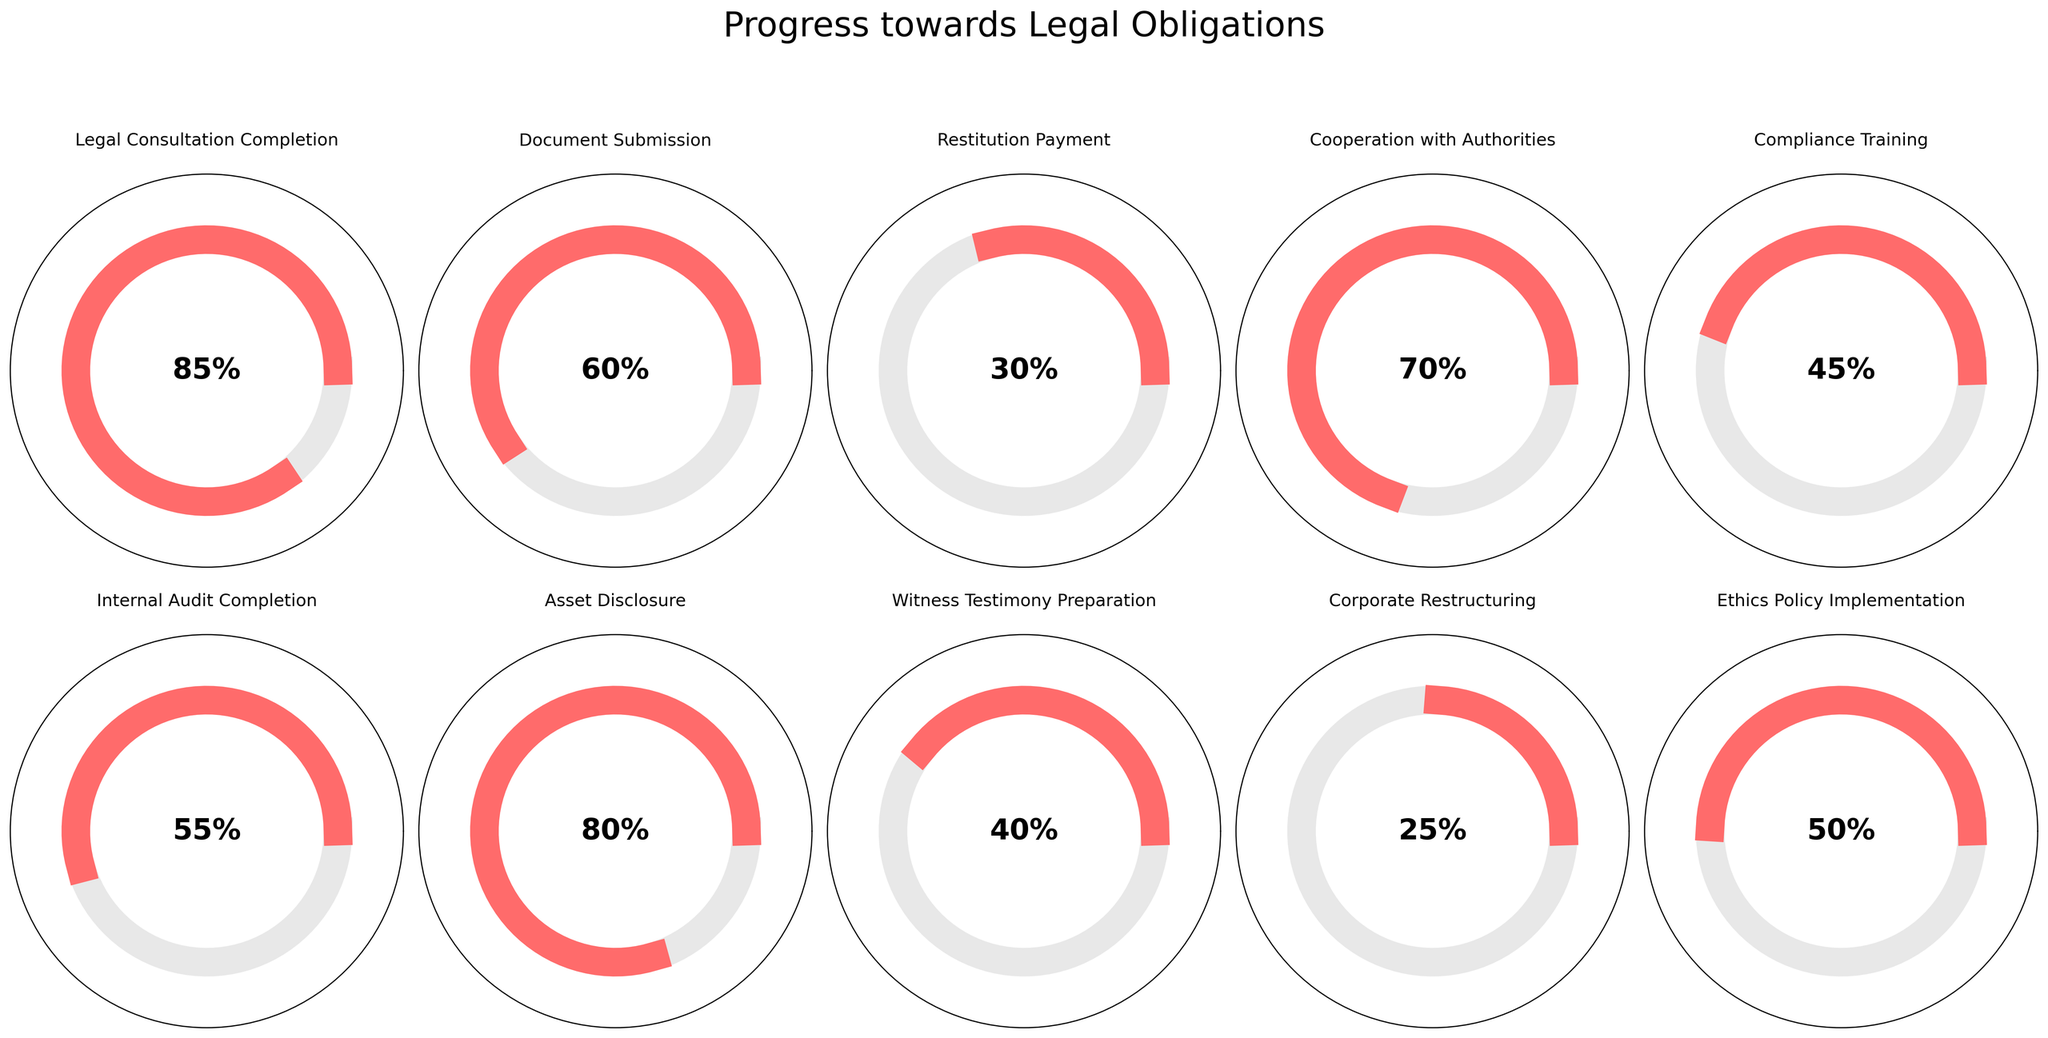What's the title of the figure? The title is usually positioned at the top of the figure. In this case, it reads "Progress towards Legal Obligations".
Answer: Progress towards Legal Obligations How many categories are displayed in the figure? There are ten individual gauges in the figure, each representing a category of progress.
Answer: 10 Which category has the highest progress percentage? By comparing the values displayed in the center of each gauge, the "Legal Consultation Completion" category shows the highest progress percentage at 85%.
Answer: Legal Consultation Completion What is the progress percentage for Document Submission? The gauge for "Document Submission" shows a value of 60% in its center.
Answer: 60% What is the combined progress percentage for Restitution Payment and Compliance Training? The Restitution Payment category has a progress percentage of 30%, and Compliance Training has 45%. Adding these together: 30 + 45 = 75%.
Answer: 75% How much more progress does Cooperation with Authorities have compared to Witness Testimony Preparation? The progress for "Cooperation with Authorities" is 70%, and for "Witness Testimony Preparation" it is 40%. The difference is 70% - 40% = 30%.
Answer: 30% What is the median progress percentage among all ten categories? Sort the progress percentages: 25, 30, 40, 45, 50, 55, 60, 70, 80, and 85. The median is the average of the 5th and 6th values in this sorted list: (50 + 55) / 2 = 52.5.
Answer: 52.5 Which categories have a progress percentage below 50%? By checking each gauge, the categories below 50% are Restitution Payment (30%), Witness Testimony Preparation (40%), Corporate Restructuring (25%), and Compliance Training (45%).
Answer: Restitution Payment, Witness Testimony Preparation, Corporate Restructuring, Compliance Training If the average progress across all categories must be at least 50%, how far must the Corporate Restructuring progress increase to meet this goal? Currently, the sum of all progress percentages is 85 + 60 + 30 + 70 + 45 + 55 + 80 + 40 + 25 + 50 = 540. The average is 540 / 10 = 54%, already above 50%. No further increase in Corporate Restructuring is needed.
Answer: 0% What are the colors used to represent progress and the background in the gauges? The progress is represented with a pinkish-red color and the uncompleted part with light gray.
Answer: pinkish-red, light gray 